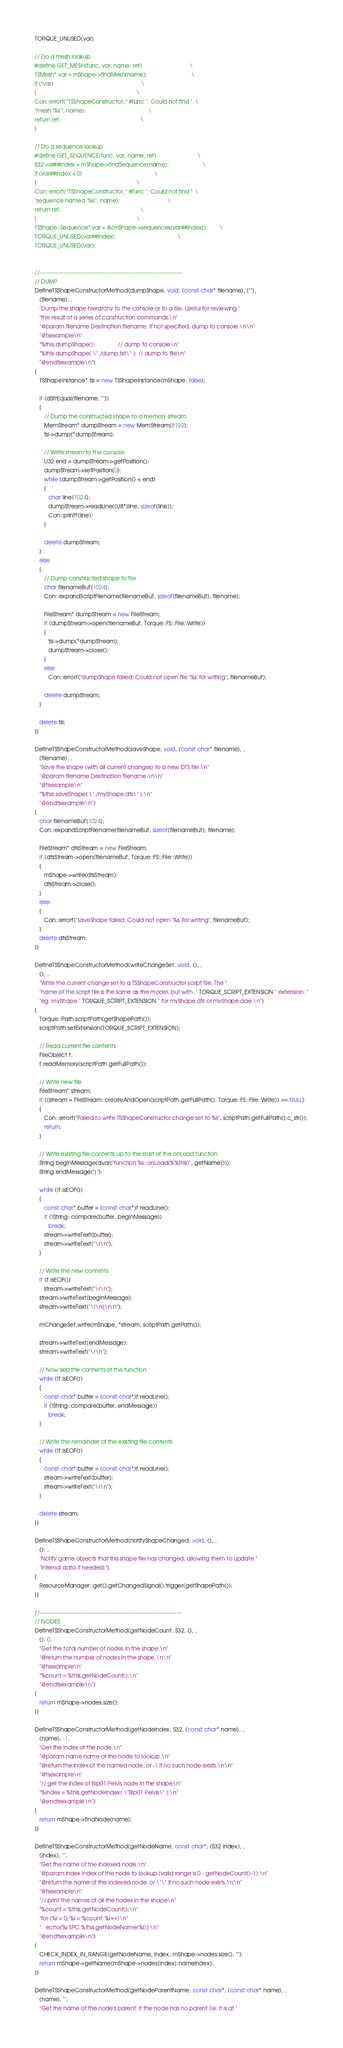<code> <loc_0><loc_0><loc_500><loc_500><_C++_>TORQUE_UNUSED(var)

// Do a mesh lookup
#define GET_MESH(func, var, name, ret)                               \
TSMesh* var = mShape->findMesh(name);                             \
if (!var)                                                         \
{                                                                 \
Con::errorf( "TSShapeConstructor::" #func ": Could not find "  \
"mesh '%s'", name);                                         \
return ret;                                                    \
}

// Do a sequence lookup
#define GET_SEQUENCE(func, var, name, ret)                           \
S32 var##Index = mShape->findSequence(name);                      \
if (var##Index < 0)                                               \
{                                                                 \
Con::errorf( "TSShapeConstructor::" #func ": Could not find "  \
"sequence named '%s'", name);                               \
return ret;                                                    \
}                                                                 \
TSShape::Sequence* var = &(mShape->sequences[var##Index]);        \
TORQUE_UNUSED(var##Index);                                        \
TORQUE_UNUSED(var);


//-----------------------------------------------------------------------------
// DUMP
DefineTSShapeConstructorMethod(dumpShape, void, (const char* filename), (""),
   (filename), ,
   "Dump the shape hierarchy to the console or to a file. Useful for reviewing "
   "the result of a series of construction commands.\n"
   "@param filename Destination filename. If not specified, dump to console.\n\n"
   "@tsexample\n"
   "%this.dumpShape();               // dump to console\n"
   "%this.dumpShape( \"./dump.txt\" ); // dump to file\n"
   "@endtsexample\n")
{
   TSShapeInstance* tsi = new TSShapeInstance(mShape, false);

   if (dStrEqual(filename, ""))
   {
      // Dump the constructed shape to a memory stream
      MemStream* dumpStream = new MemStream(8192);
      tsi->dump(*dumpStream);

      // Write stream to the console
      U32 end = dumpStream->getPosition();
      dumpStream->setPosition(0);
      while (dumpStream->getPosition() < end)
      {
         char line[1024];
         dumpStream->readLine((U8*)line, sizeof(line));
         Con::printf(line);
      }

      delete dumpStream;
   }
   else
   {
      // Dump constructed shape to file
      char filenameBuf[1024];
      Con::expandScriptFilename(filenameBuf, sizeof(filenameBuf), filename);

      FileStream* dumpStream = new FileStream;
      if (dumpStream->open(filenameBuf, Torque::FS::File::Write))
      {
         tsi->dump(*dumpStream);
         dumpStream->close();
      }
      else
         Con::errorf("dumpShape failed: Could not open file '%s' for writing", filenameBuf);

      delete dumpStream;
   }

   delete tsi;
}}

DefineTSShapeConstructorMethod(saveShape, void, (const char* filename), ,
   (filename), ,
   "Save the shape (with all current changes) to a new DTS file.\n"
   "@param filename Destination filename.\n\n"
   "@tsexample\n"
   "%this.saveShape( \"./myShape.dts\" );\n"
   "@endtsexample\n")
{
   char filenameBuf[1024];
   Con::expandScriptFilename(filenameBuf, sizeof(filenameBuf), filename);

   FileStream* dtsStream = new FileStream;
   if (dtsStream->open(filenameBuf, Torque::FS::File::Write))
   {
      mShape->write(dtsStream);
      dtsStream->close();
   }
   else
   {
      Con::errorf("saveShape failed: Could not open '%s' for writing", filenameBuf);
   }
   delete dtsStream;
}}

DefineTSShapeConstructorMethod(writeChangeSet, void, (), ,
   (), ,
   "Write the current change set to a TSShapeConstructor script file. The "
   "name of the script file is the same as the model, but with ." TORQUE_SCRIPT_EXTENSION " extension. "
   "eg. myShape." TORQUE_SCRIPT_EXTENSION " for myShape.dts or myShape.dae.\n")
{
   Torque::Path scriptPath(getShapePath());
   scriptPath.setExtension(TORQUE_SCRIPT_EXTENSION);

   // Read current file contents
   FileObject f;
   f.readMemory(scriptPath.getFullPath());

   // Write new file
   FileStream* stream;
   if ((stream = FileStream::createAndOpen(scriptPath.getFullPath(), Torque::FS::File::Write)) == NULL)
   {
      Con::errorf("Failed to write TSShapeConstructor change set to %s", scriptPath.getFullPath().c_str());
      return;
   }

   // Write existing file contents up to the start of the onLoad function
   String beginMessage(avar("function %s::onLoad(%%this)", getName()));
   String endMessage("}");

   while (!f.isEOF())
   {
      const char* buffer = (const char*)f.readLine();
      if (!String::compare(buffer, beginMessage))
         break;
      stream->writeText(buffer);
      stream->writeText("\r\n");
   }

   // Write the new contents
   if (f.isEOF())
      stream->writeText("\r\n");
   stream->writeText(beginMessage);
   stream->writeText("\r\n{\r\n");

   mChangeSet.write(mShape, *stream, scriptPath.getPath());

   stream->writeText(endMessage);
   stream->writeText("\r\n");

   // Now skip the contents of the function
   while (!f.isEOF())
   {
      const char* buffer = (const char*)f.readLine();
      if (!String::compare(buffer, endMessage))
         break;
   }

   // Write the remainder of the existing file contents
   while (!f.isEOF())
   {
      const char* buffer = (const char*)f.readLine();
      stream->writeText(buffer);
      stream->writeText("\r\n");
   }

   delete stream;
}}

DefineTSShapeConstructorMethod(notifyShapeChanged, void, (), ,
   (), ,
   "Notify game objects that this shape file has changed, allowing them to update "
   "internal data if needed.")
{
   ResourceManager::get().getChangedSignal().trigger(getShapePath());
}}

//-----------------------------------------------------------------------------
// NODES
DefineTSShapeConstructorMethod(getNodeCount, S32, (), ,
   (), 0,
   "Get the total number of nodes in the shape.\n"
   "@return the number of nodes in the shape.\n\n"
   "@tsexample\n"
   "%count = %this.getNodeCount();\n"
   "@endtsexample\n")
{
   return mShape->nodes.size();
}}

DefineTSShapeConstructorMethod(getNodeIndex, S32, (const char* name), ,
   (name), -1,
   "Get the index of the node.\n"
   "@param name name of the node to lookup.\n"
   "@return the index of the named node, or -1 if no such node exists.\n\n"
   "@tsexample\n"
   "// get the index of Bip01 Pelvis node in the shape\n"
   "%index = %this.getNodeIndex( \"Bip01 Pelvis\" );\n"
   "@endtsexample\n")
{
   return mShape->findNode(name);
}}

DefineTSShapeConstructorMethod(getNodeName, const char*, (S32 index), ,
   (index), "",
   "Get the name of the indexed node.\n"
   "@param index index of the node to lookup (valid range is 0 - getNodeCount()-1).\n"
   "@return the name of the indexed node, or \"\" if no such node exists.\n\n"
   "@tsexample\n"
   "// print the names of all the nodes in the shape\n"
   "%count = %this.getNodeCount();\n"
   "for (%i = 0; %i < %count; %i++)\n"
   "   echo(%i SPC %this.getNodeName(%i));\n"
   "@endtsexample\n")
{
   CHECK_INDEX_IN_RANGE(getNodeName, index, mShape->nodes.size(), "");
   return mShape->getName(mShape->nodes[index].nameIndex);
}}

DefineTSShapeConstructorMethod(getNodeParentName, const char*, (const char* name), ,
   (name), "",
   "Get the name of the node's parent. If the node has no parent (ie. it is at "</code> 